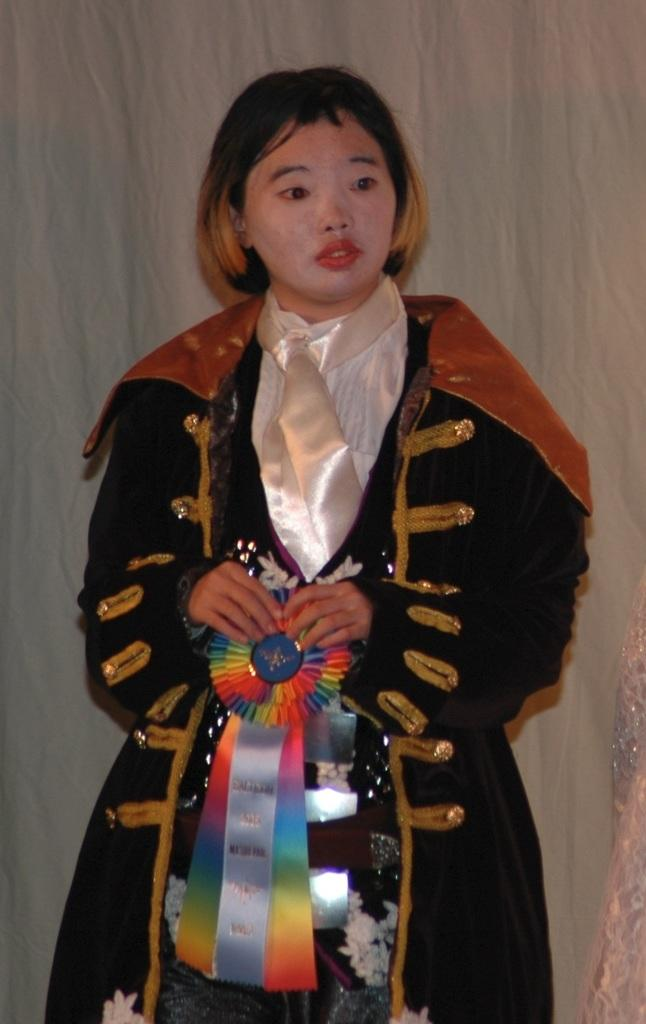Who is present in the image? There is a woman in the image. What is the woman doing in the image? The woman is standing in the image. What is the woman wearing in the image? The woman is wearing a costume in the image. What can be seen in the background of the image? There is a white curtain in the background of the image. Where is the woman reading a book in the image? There is no book or reading activity depicted in the image. 